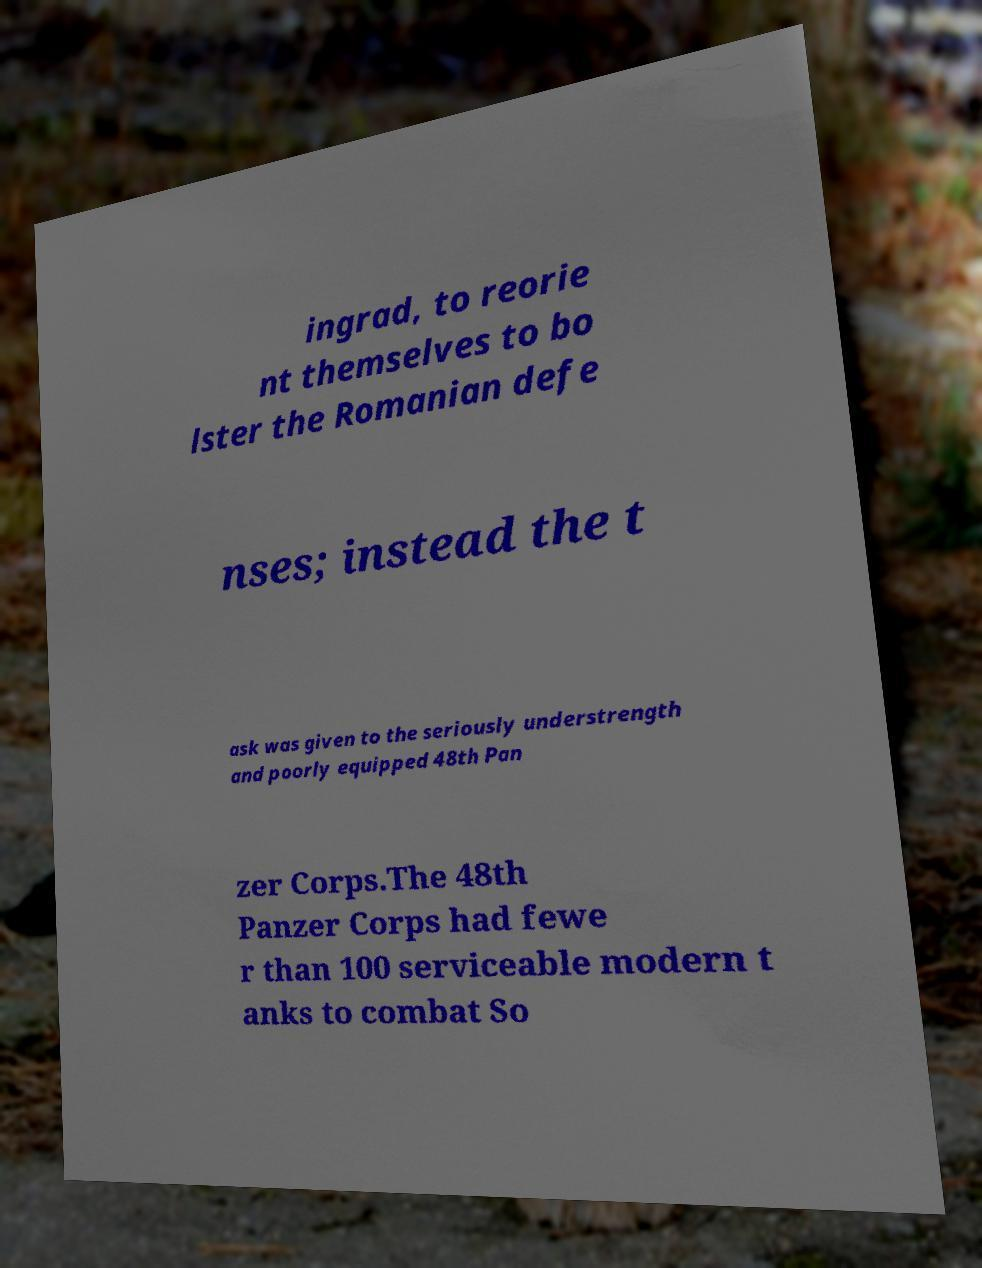Please identify and transcribe the text found in this image. ingrad, to reorie nt themselves to bo lster the Romanian defe nses; instead the t ask was given to the seriously understrength and poorly equipped 48th Pan zer Corps.The 48th Panzer Corps had fewe r than 100 serviceable modern t anks to combat So 